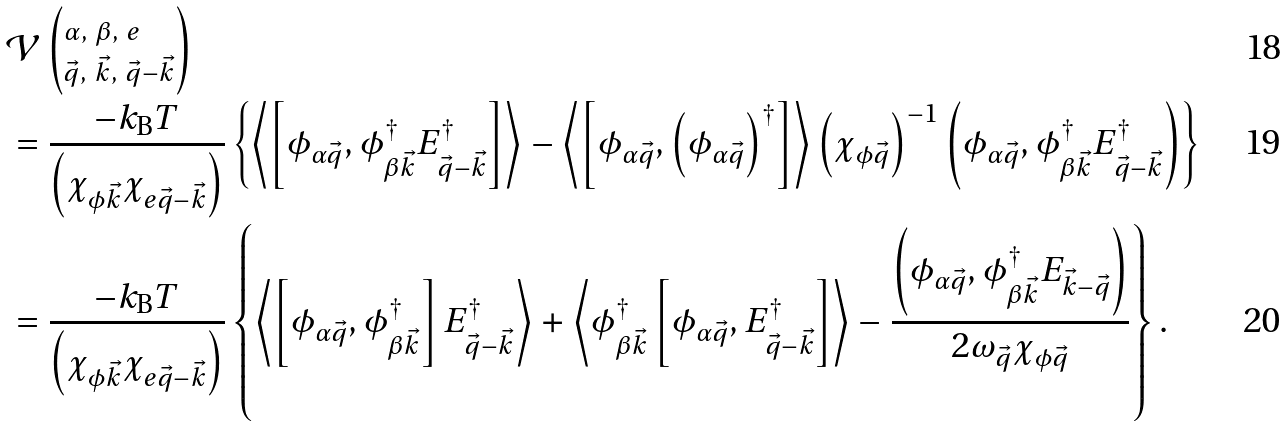<formula> <loc_0><loc_0><loc_500><loc_500>& \mathcal { V } \left ( _ { \vec { q } , \ \vec { k } , \ \vec { q } - \vec { k } } ^ { \alpha , \ \beta , \ e } \right ) \\ & = \frac { - k _ { \text  B}T} {\left(\chi_{\phi\vec{k} } \chi _ { e \vec { q } - \vec { k } } \right ) } \left \{ \left \langle \left [ \phi _ { \alpha \vec { q } } , \phi _ { \beta \vec { k } } ^ { \dagger } E _ { \vec { q } - \vec { k } } ^ { \dagger } \right ] \right \rangle - \left \langle \left [ \phi _ { \alpha \vec { q } } , \left ( \phi _ { \alpha \vec { q } } \right ) ^ { \dagger } \right ] \right \rangle \left ( \chi _ { \phi \vec { q } } \right ) ^ { - 1 } \left ( \phi _ { \alpha \vec { q } } , \phi _ { \beta \vec { k } } ^ { \dagger } E _ { \vec { q } - \vec { k } } ^ { \dagger } \right ) \right \} \\ & = \frac { - k _ { \text  B}T} {\left(\chi_{\phi\vec{k} } \chi _ { e \vec { q } - \vec { k } } \right ) } \left \{ \left \langle \left [ \phi _ { \alpha \vec { q } } , \phi _ { \beta \vec { k } } ^ { \dagger } \right ] E _ { \vec { q } - \vec { k } } ^ { \dagger } \right \rangle + \left \langle \phi _ { \beta \vec { k } } ^ { \dagger } \left [ \phi _ { \alpha \vec { q } } , E _ { \vec { q } - \vec { k } } ^ { \dagger } \right ] \right \rangle - \frac { \left ( \phi _ { \alpha \vec { q } } , \phi _ { \beta \vec { k } } ^ { \dagger } E _ { \vec { k } - \vec { q } } \right ) } { 2 \omega _ { \vec { q } } \chi _ { \phi \vec { q } } } \right \} .</formula> 